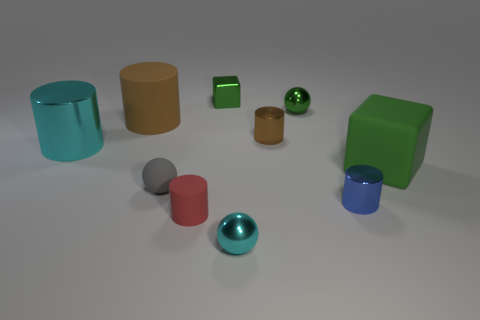Subtract all cyan cylinders. How many cylinders are left? 4 Subtract all tiny brown metallic cylinders. How many cylinders are left? 4 Subtract all purple cylinders. Subtract all cyan balls. How many cylinders are left? 5 Subtract all spheres. How many objects are left? 7 Add 6 small spheres. How many small spheres exist? 9 Subtract 0 yellow balls. How many objects are left? 10 Subtract all large green cubes. Subtract all tiny metallic things. How many objects are left? 4 Add 1 tiny shiny cylinders. How many tiny shiny cylinders are left? 3 